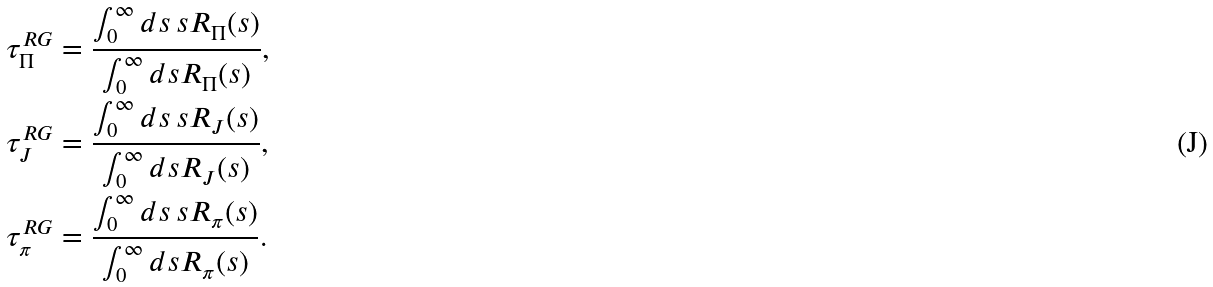Convert formula to latex. <formula><loc_0><loc_0><loc_500><loc_500>\tau ^ { R G } _ { \Pi } & = \frac { \int _ { 0 } ^ { \infty } d s \, s R _ { \Pi } ( s ) } { \int _ { 0 } ^ { \infty } d s R _ { \Pi } ( s ) } , \\ \tau ^ { R G } _ { J } & = \frac { \int _ { 0 } ^ { \infty } d s \, s R _ { J } ( s ) } { \int _ { 0 } ^ { \infty } d s R _ { J } ( s ) } , \\ \tau ^ { R G } _ { \pi } & = \frac { \int _ { 0 } ^ { \infty } d s \, s R _ { \pi } ( s ) } { \int _ { 0 } ^ { \infty } d s R _ { \pi } ( s ) } .</formula> 